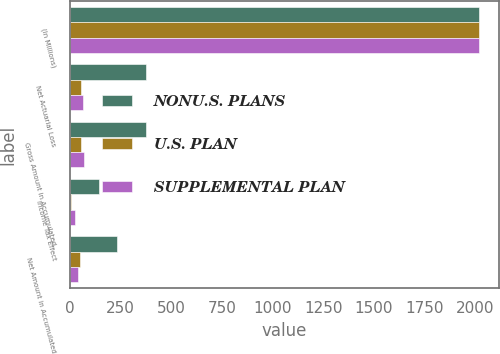Convert chart. <chart><loc_0><loc_0><loc_500><loc_500><stacked_bar_chart><ecel><fcel>(In Millions)<fcel>Net Actuarial Loss<fcel>Gross Amount in Accumulated<fcel>Income Tax Effect<fcel>Net Amount in Accumulated<nl><fcel>NONU.S. PLANS<fcel>2016<fcel>378.1<fcel>375.8<fcel>142.3<fcel>233.5<nl><fcel>U.S. PLAN<fcel>2016<fcel>55.8<fcel>55.8<fcel>6.7<fcel>49.1<nl><fcel>SUPPLEMENTAL PLAN<fcel>2016<fcel>67.4<fcel>68.2<fcel>25.8<fcel>42.4<nl></chart> 